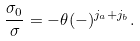<formula> <loc_0><loc_0><loc_500><loc_500>\frac { \sigma _ { 0 } } { \sigma } = - \theta ( - ) ^ { j _ { a } + j _ { b } } .</formula> 